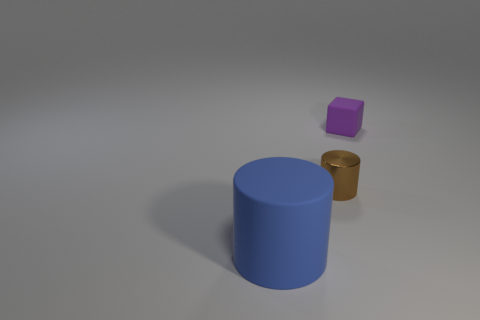There is a blue object that is the same shape as the brown metallic object; what is it made of?
Make the answer very short. Rubber. Do the brown metal thing and the purple rubber object have the same shape?
Offer a terse response. No. There is a big blue rubber object; what number of blue cylinders are left of it?
Provide a short and direct response. 0. What is the shape of the matte thing behind the rubber object in front of the small metallic thing?
Provide a succinct answer. Cube. There is a thing that is the same material as the small purple cube; what is its shape?
Your answer should be very brief. Cylinder. Is the size of the cylinder that is behind the large blue rubber thing the same as the matte object that is in front of the small purple cube?
Make the answer very short. No. There is a matte object that is to the right of the blue object; what is its shape?
Your answer should be very brief. Cube. What is the color of the small matte object?
Offer a very short reply. Purple. Does the rubber cylinder have the same size as the cylinder that is to the right of the big object?
Provide a short and direct response. No. How many rubber things are small purple things or tiny purple cylinders?
Provide a succinct answer. 1. 